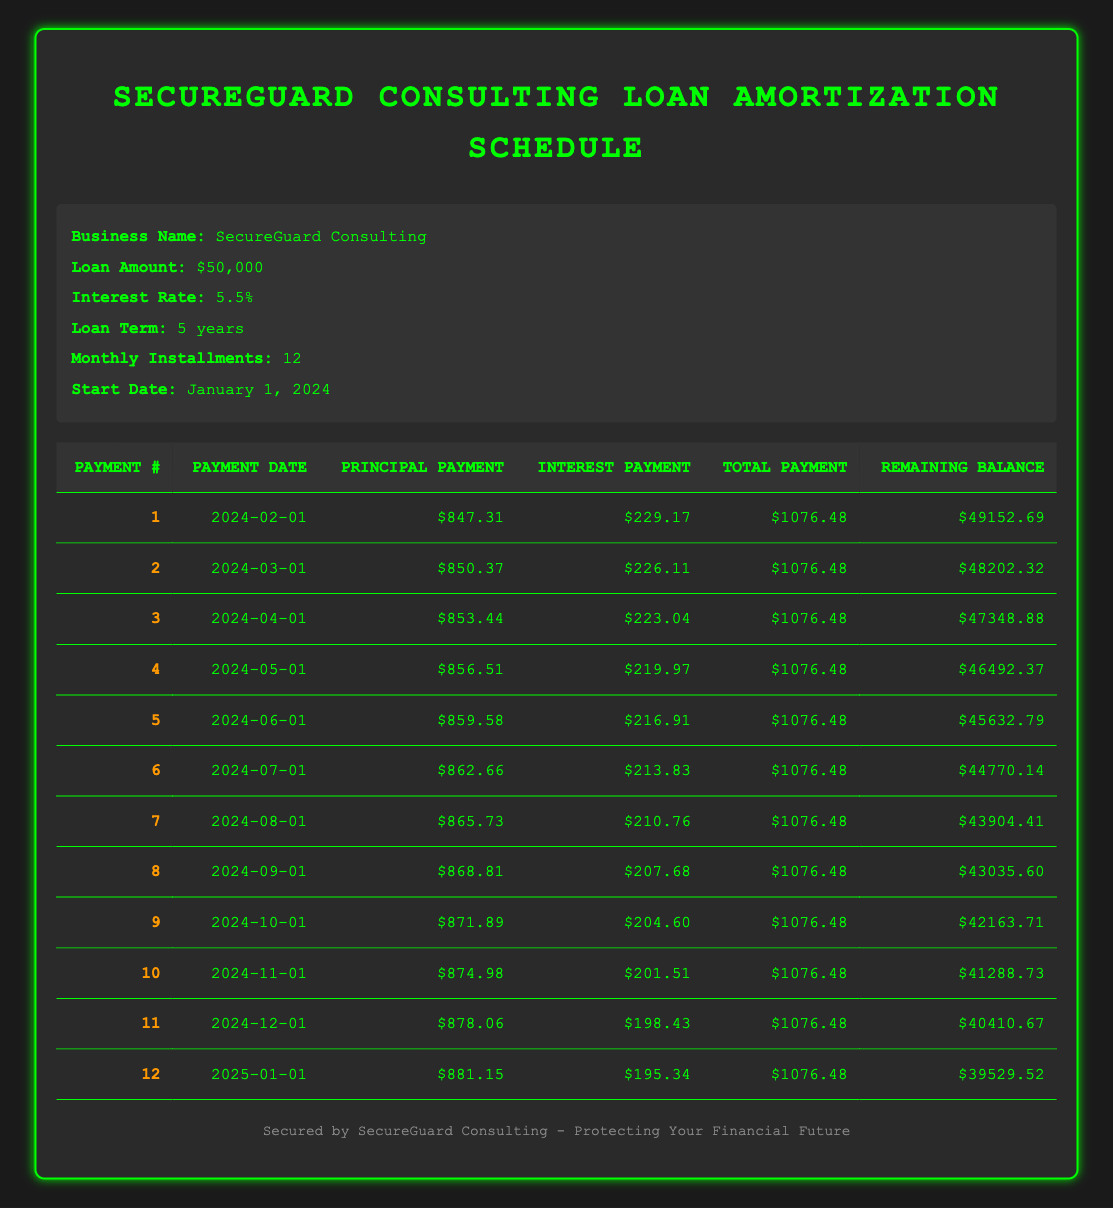What is the total loan amount for SecureGuard Consulting? The loan amount is stated clearly in the loan details section of the table, which shows the figure $50,000.
Answer: 50000 What is the interest payment for the first installment? The table lists the interest payment for the first payment specifically as $229.17 in the respective column.
Answer: 229.17 How much is the remaining balance after the 6th payment? The remaining balance is provided in the table for the 6th payment, which shows $44,770.14 in the corresponding column.
Answer: 44770.14 What is the total payment amount for the 12th installment? The total payment for the 12th installment is shown in that row as $1,076.48, which is the value in the total payment column.
Answer: 1076.48 What is the average principal payment for the first 3 installments? The principal payments for the first three installments are $847.31, $850.37, and $853.44. Their sum (847.31 + 850.37 + 853.44 = 2551.12) divided by 3 gives an average of $850.37.
Answer: 850.37 Is the total payment consistent across all installments? By examining the total payment column, it can be seen that each payment is $1,076.48, confirming that the total payment remains consistent.
Answer: Yes How much has been paid in principal and interest combined after the first two installments? The total amount paid after the first two installments is the sum of the principal payments ($847.31 + $850.37) and the interest payments ($229.17 + $226.11). So, the combined total is $2,156.96.
Answer: 2156.96 What is the decrease in the remaining balance from the 1st to the 12th payment? The remaining balance after the 1st payment is $49,152.69, and after the 12th payment, it is $39,529.52. The decrease is calculated as $49,152.69 - $39,529.52, which equals $9,623.17.
Answer: 9623.17 How much interest will be paid in total after 12 installments? Summing the interest payments for each of the 12 installments from the table gives a total of $2,562.52. This is calculated by adding all the individual interest payments displayed in the table.
Answer: 2562.52 